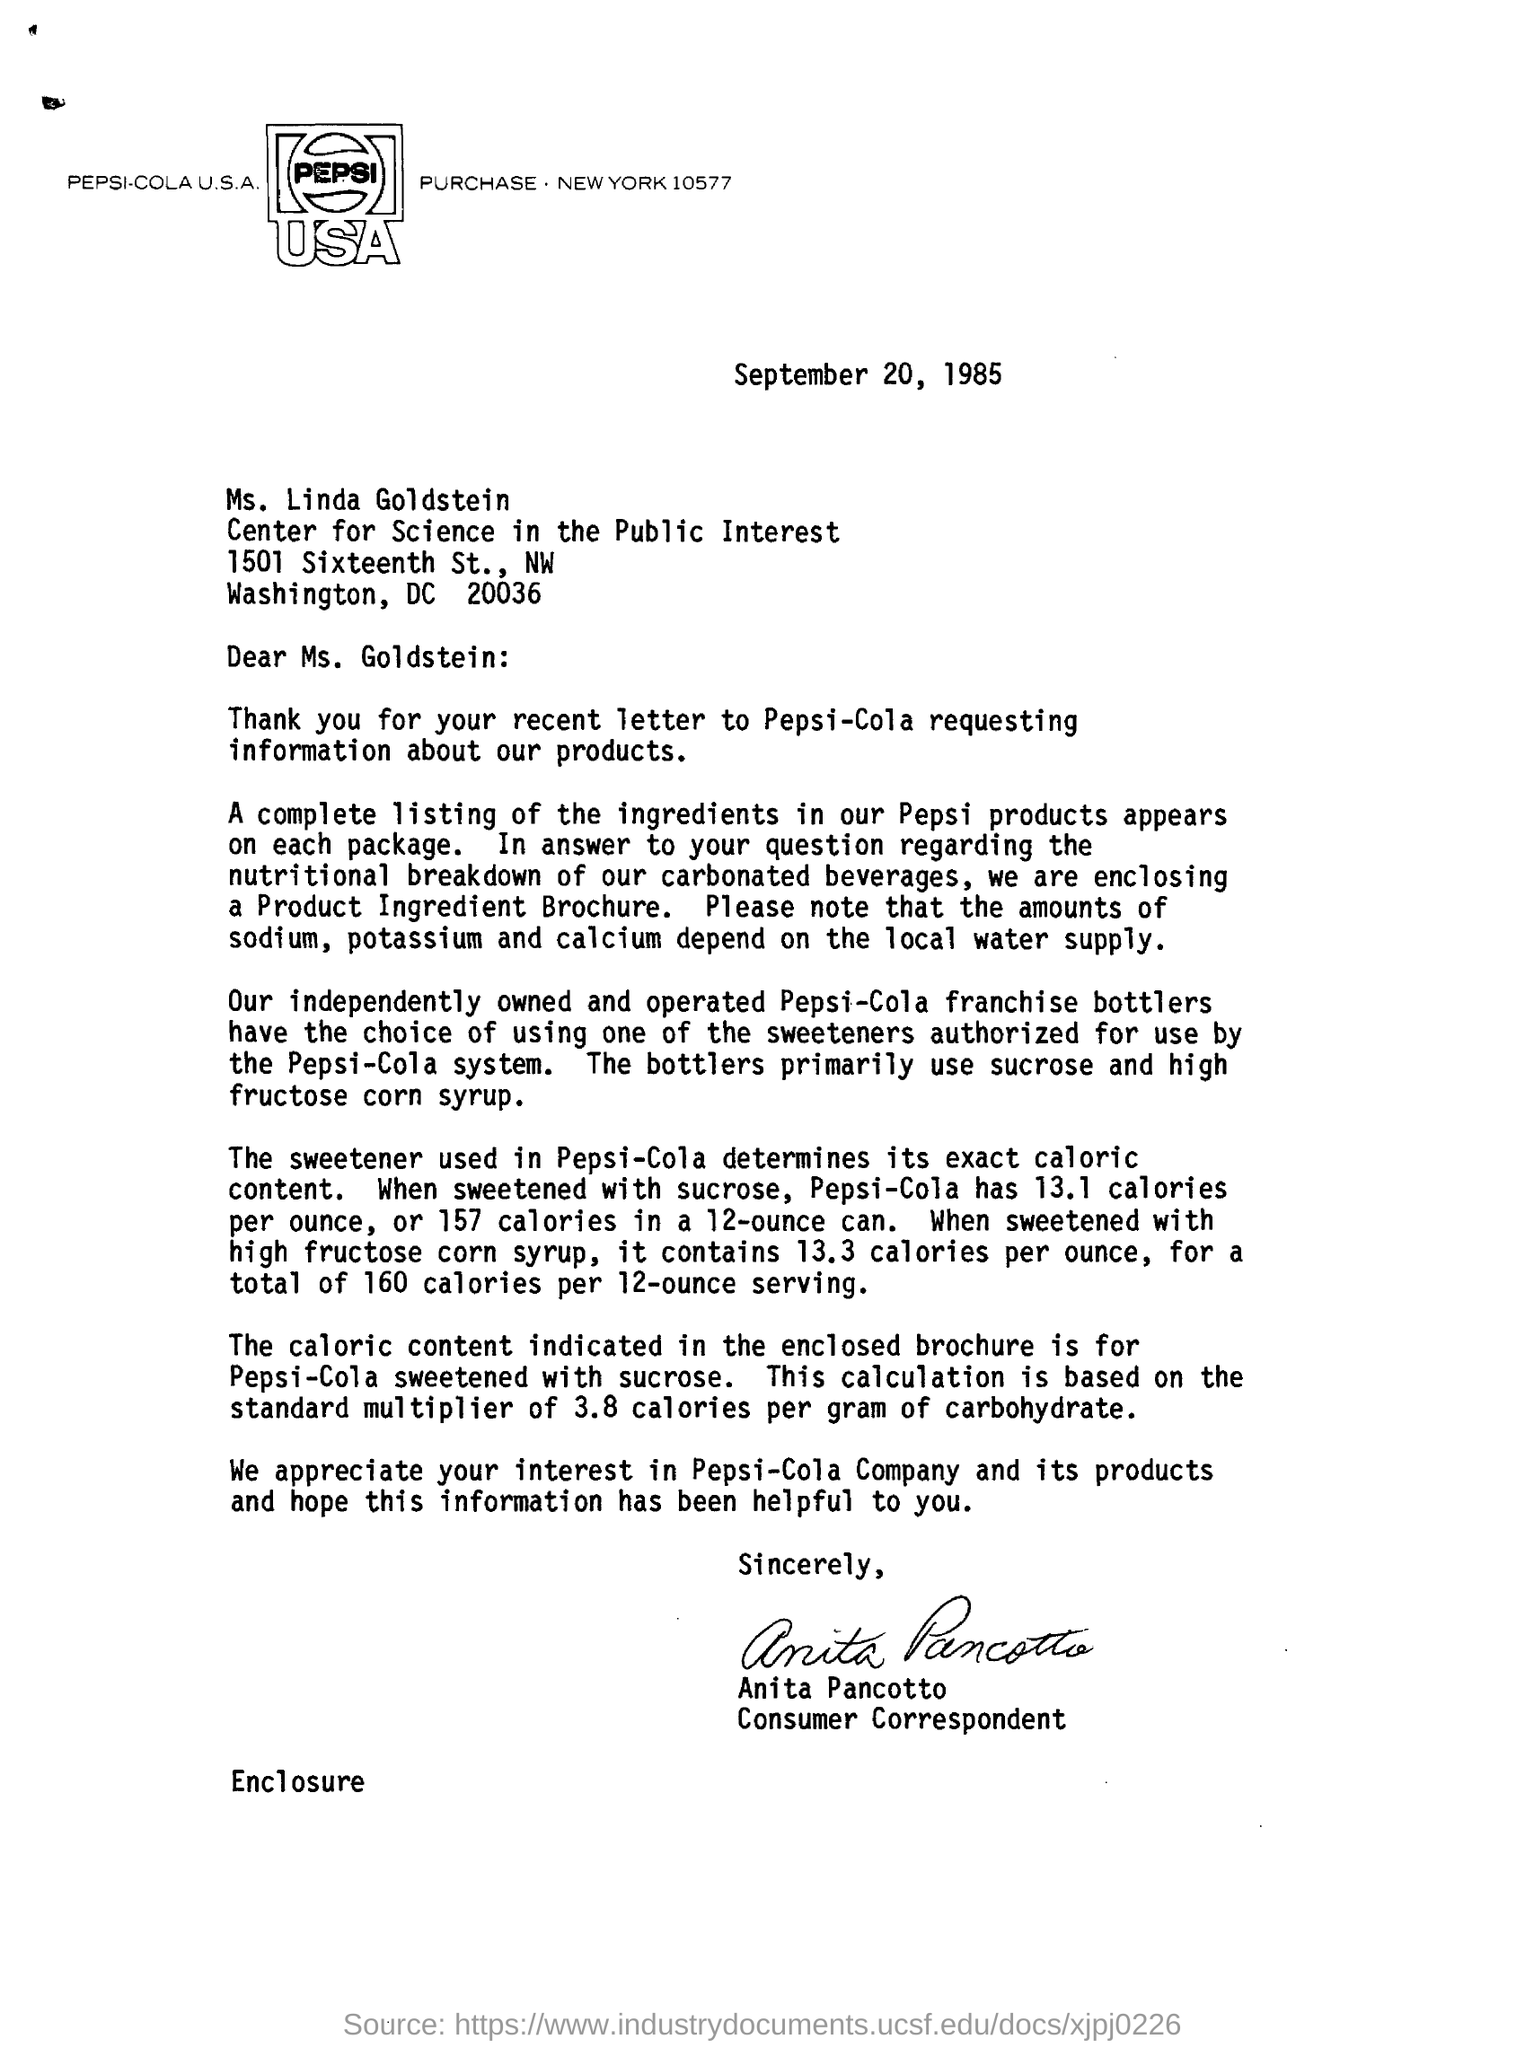What is the date mentioned?
Give a very brief answer. September 20, 1985. To whom is this letter addressed?
Provide a short and direct response. Ms. Linda Goldstein. The amounts of which elements depend on the local water supply?
Your answer should be very brief. Sodium, potassium and calcium. Where does the complete listing of ingredients in Pepsi products appear?
Give a very brief answer. On each package. 